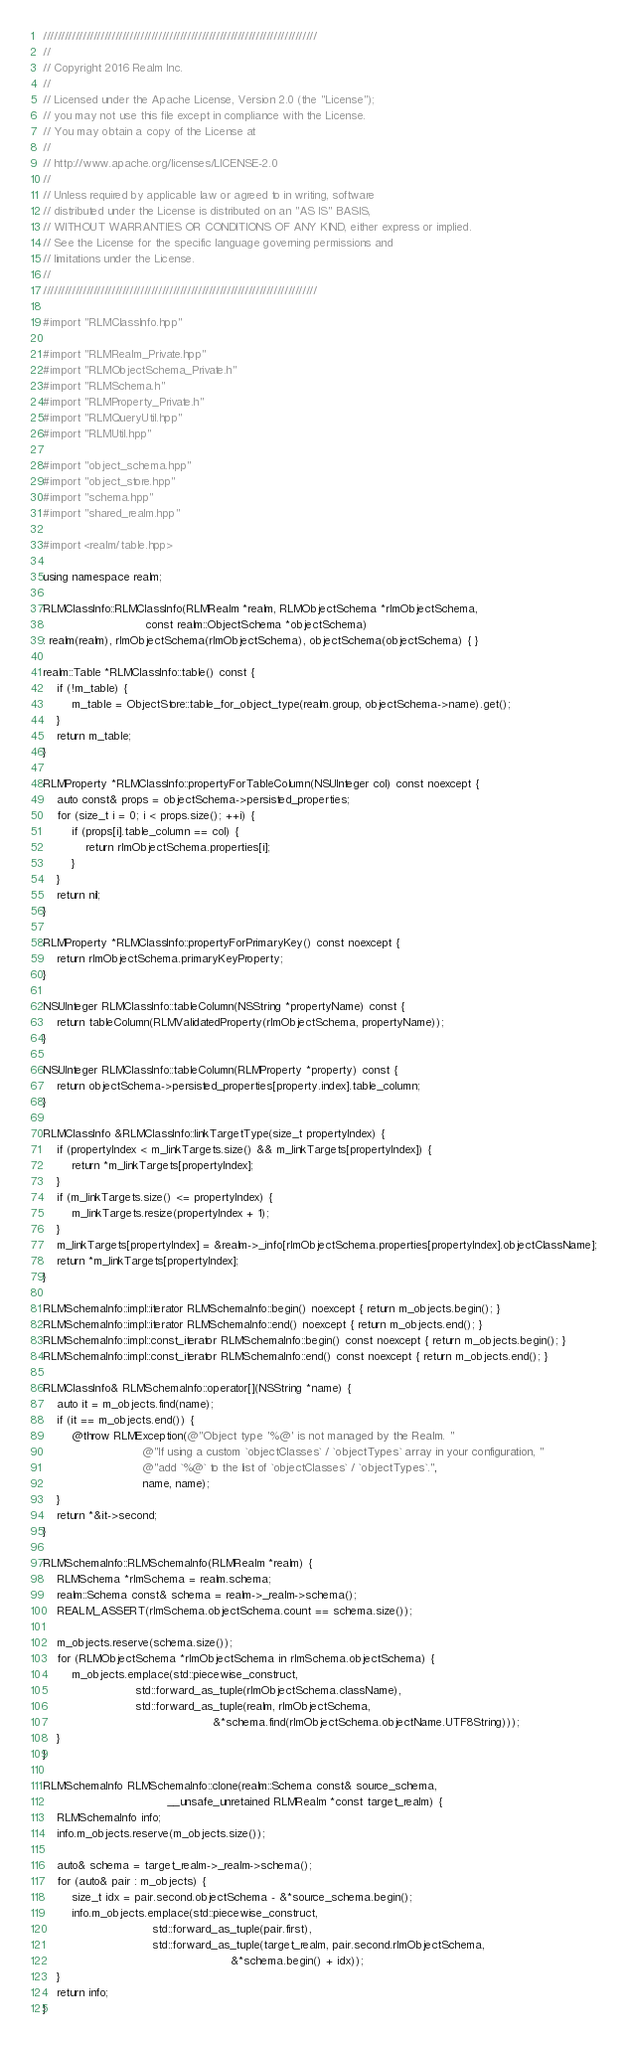<code> <loc_0><loc_0><loc_500><loc_500><_ObjectiveC_>////////////////////////////////////////////////////////////////////////////
//
// Copyright 2016 Realm Inc.
//
// Licensed under the Apache License, Version 2.0 (the "License");
// you may not use this file except in compliance with the License.
// You may obtain a copy of the License at
//
// http://www.apache.org/licenses/LICENSE-2.0
//
// Unless required by applicable law or agreed to in writing, software
// distributed under the License is distributed on an "AS IS" BASIS,
// WITHOUT WARRANTIES OR CONDITIONS OF ANY KIND, either express or implied.
// See the License for the specific language governing permissions and
// limitations under the License.
//
////////////////////////////////////////////////////////////////////////////

#import "RLMClassInfo.hpp"

#import "RLMRealm_Private.hpp"
#import "RLMObjectSchema_Private.h"
#import "RLMSchema.h"
#import "RLMProperty_Private.h"
#import "RLMQueryUtil.hpp"
#import "RLMUtil.hpp"

#import "object_schema.hpp"
#import "object_store.hpp"
#import "schema.hpp"
#import "shared_realm.hpp"

#import <realm/table.hpp>

using namespace realm;

RLMClassInfo::RLMClassInfo(RLMRealm *realm, RLMObjectSchema *rlmObjectSchema,
                             const realm::ObjectSchema *objectSchema)
: realm(realm), rlmObjectSchema(rlmObjectSchema), objectSchema(objectSchema) { }

realm::Table *RLMClassInfo::table() const {
    if (!m_table) {
        m_table = ObjectStore::table_for_object_type(realm.group, objectSchema->name).get();
    }
    return m_table;
}

RLMProperty *RLMClassInfo::propertyForTableColumn(NSUInteger col) const noexcept {
    auto const& props = objectSchema->persisted_properties;
    for (size_t i = 0; i < props.size(); ++i) {
        if (props[i].table_column == col) {
            return rlmObjectSchema.properties[i];
        }
    }
    return nil;
}

RLMProperty *RLMClassInfo::propertyForPrimaryKey() const noexcept {
    return rlmObjectSchema.primaryKeyProperty;
}

NSUInteger RLMClassInfo::tableColumn(NSString *propertyName) const {
    return tableColumn(RLMValidatedProperty(rlmObjectSchema, propertyName));
}

NSUInteger RLMClassInfo::tableColumn(RLMProperty *property) const {
    return objectSchema->persisted_properties[property.index].table_column;
}

RLMClassInfo &RLMClassInfo::linkTargetType(size_t propertyIndex) {
    if (propertyIndex < m_linkTargets.size() && m_linkTargets[propertyIndex]) {
        return *m_linkTargets[propertyIndex];
    }
    if (m_linkTargets.size() <= propertyIndex) {
        m_linkTargets.resize(propertyIndex + 1);
    }
    m_linkTargets[propertyIndex] = &realm->_info[rlmObjectSchema.properties[propertyIndex].objectClassName];
    return *m_linkTargets[propertyIndex];
}

RLMSchemaInfo::impl::iterator RLMSchemaInfo::begin() noexcept { return m_objects.begin(); }
RLMSchemaInfo::impl::iterator RLMSchemaInfo::end() noexcept { return m_objects.end(); }
RLMSchemaInfo::impl::const_iterator RLMSchemaInfo::begin() const noexcept { return m_objects.begin(); }
RLMSchemaInfo::impl::const_iterator RLMSchemaInfo::end() const noexcept { return m_objects.end(); }

RLMClassInfo& RLMSchemaInfo::operator[](NSString *name) {
    auto it = m_objects.find(name);
    if (it == m_objects.end()) {
        @throw RLMException(@"Object type '%@' is not managed by the Realm. "
                            @"If using a custom `objectClasses` / `objectTypes` array in your configuration, "
                            @"add `%@` to the list of `objectClasses` / `objectTypes`.",
                            name, name);
    }
    return *&it->second;
}

RLMSchemaInfo::RLMSchemaInfo(RLMRealm *realm) {
    RLMSchema *rlmSchema = realm.schema;
    realm::Schema const& schema = realm->_realm->schema();
    REALM_ASSERT(rlmSchema.objectSchema.count == schema.size());

    m_objects.reserve(schema.size());
    for (RLMObjectSchema *rlmObjectSchema in rlmSchema.objectSchema) {
        m_objects.emplace(std::piecewise_construct,
                          std::forward_as_tuple(rlmObjectSchema.className),
                          std::forward_as_tuple(realm, rlmObjectSchema,
                                                &*schema.find(rlmObjectSchema.objectName.UTF8String)));
    }
}

RLMSchemaInfo RLMSchemaInfo::clone(realm::Schema const& source_schema,
                                   __unsafe_unretained RLMRealm *const target_realm) {
    RLMSchemaInfo info;
    info.m_objects.reserve(m_objects.size());

    auto& schema = target_realm->_realm->schema();
    for (auto& pair : m_objects) {
        size_t idx = pair.second.objectSchema - &*source_schema.begin();
        info.m_objects.emplace(std::piecewise_construct,
                               std::forward_as_tuple(pair.first),
                               std::forward_as_tuple(target_realm, pair.second.rlmObjectSchema,
                                                     &*schema.begin() + idx));
    }
    return info;
}
</code> 